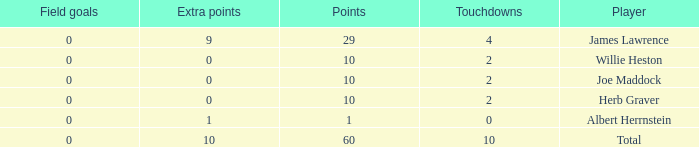What is the smallest number of field goals for players with 4 touchdowns and less than 9 extra points? None. 